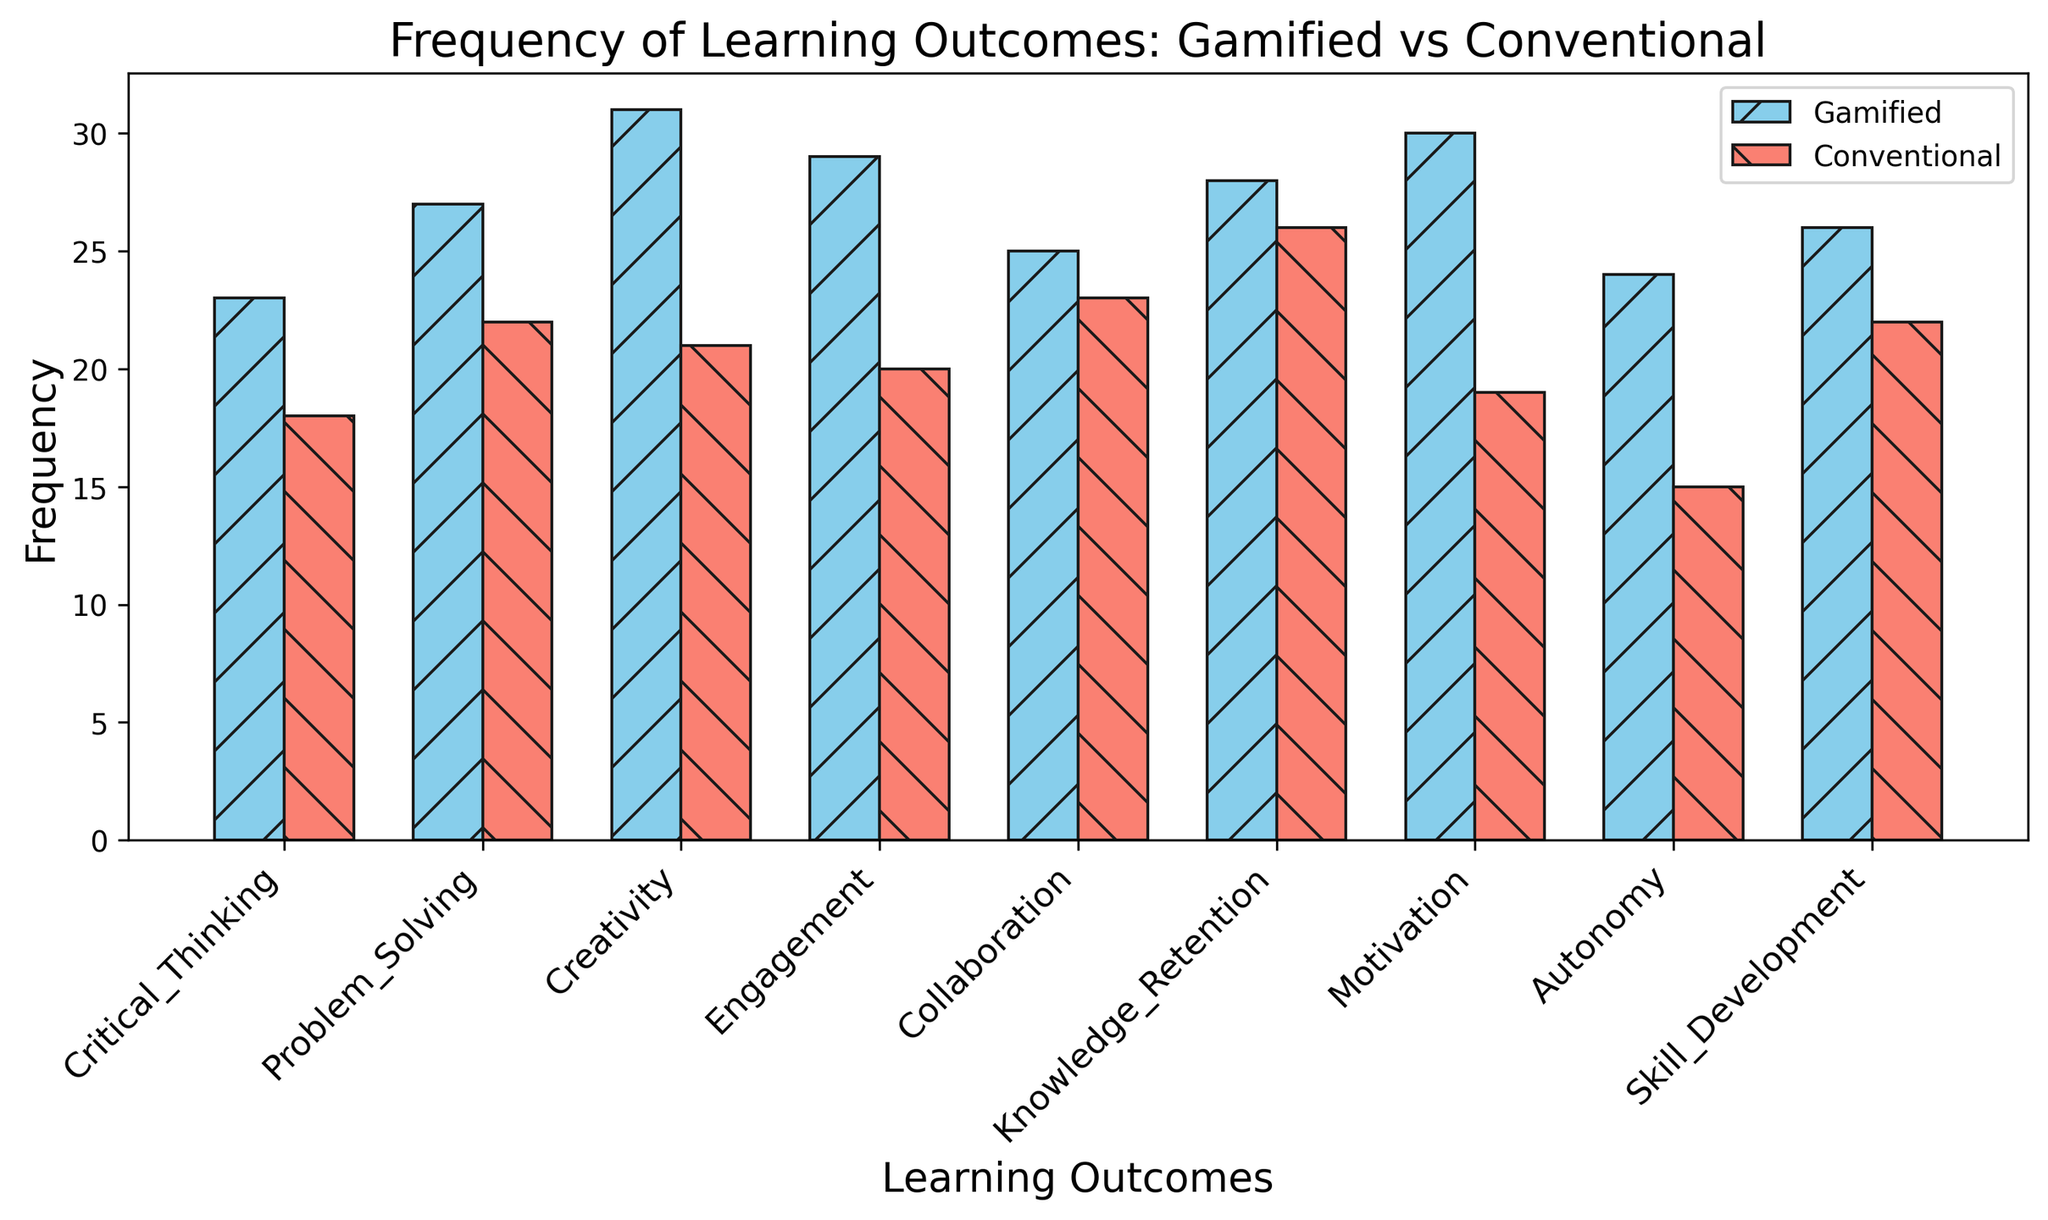What's the most frequently achieved learning outcome through gamified activities? Looking at the height of the bars for gamified activities, the highest bar corresponds to 'Creativity' with a frequency of 31.
Answer: Creativity Which learning outcome has the smallest difference in frequency between gamified and conventional activities? Calculate the difference for each outcome: Critical Thinking (5), Problem Solving (5), Creativity (10), Engagement (9), Collaboration (2), Knowledge Retention (2), Motivation (11), Autonomy (9), Skill Development (4). The smallest difference is for 'Collaboration' and 'Knowledge Retention', both with a difference of 2.
Answer: Collaboration and Knowledge Retention How many learning outcomes have a higher frequency in gamified activities than conventional activities? Compare each pair of bars: Critical Thinking (23 vs 18), Problem Solving (27 vs 22), Creativity (31 vs 21), Engagement (29 vs 20), Collaboration (25 vs 23), Knowledge Retention (28 vs 26), Motivation (30 vs 19), Autonomy (24 vs 15), Skill Development (26 vs 22). All learning outcomes have higher frequencies for gamified activities.
Answer: 9 What is the total frequency of all learning outcomes for conventional assignments? Sum the frequencies for conventional assignments: 18 + 22 + 21 + 20 + 23 + 26 + 19 + 15 + 22 = 186.
Answer: 186 Which learning outcome shows the greatest improvement when taught through gamified activities compared to conventional assignments? Calculate the difference in frequencies: Critical Thinking (5), Problem Solving (5), Creativity (10), Engagement (9), Collaboration (2), Knowledge Retention (2), Motivation (11), Autonomy (9), Skill Development (4). The greatest improvement is for 'Motivation' with a difference of 11.
Answer: Motivation 